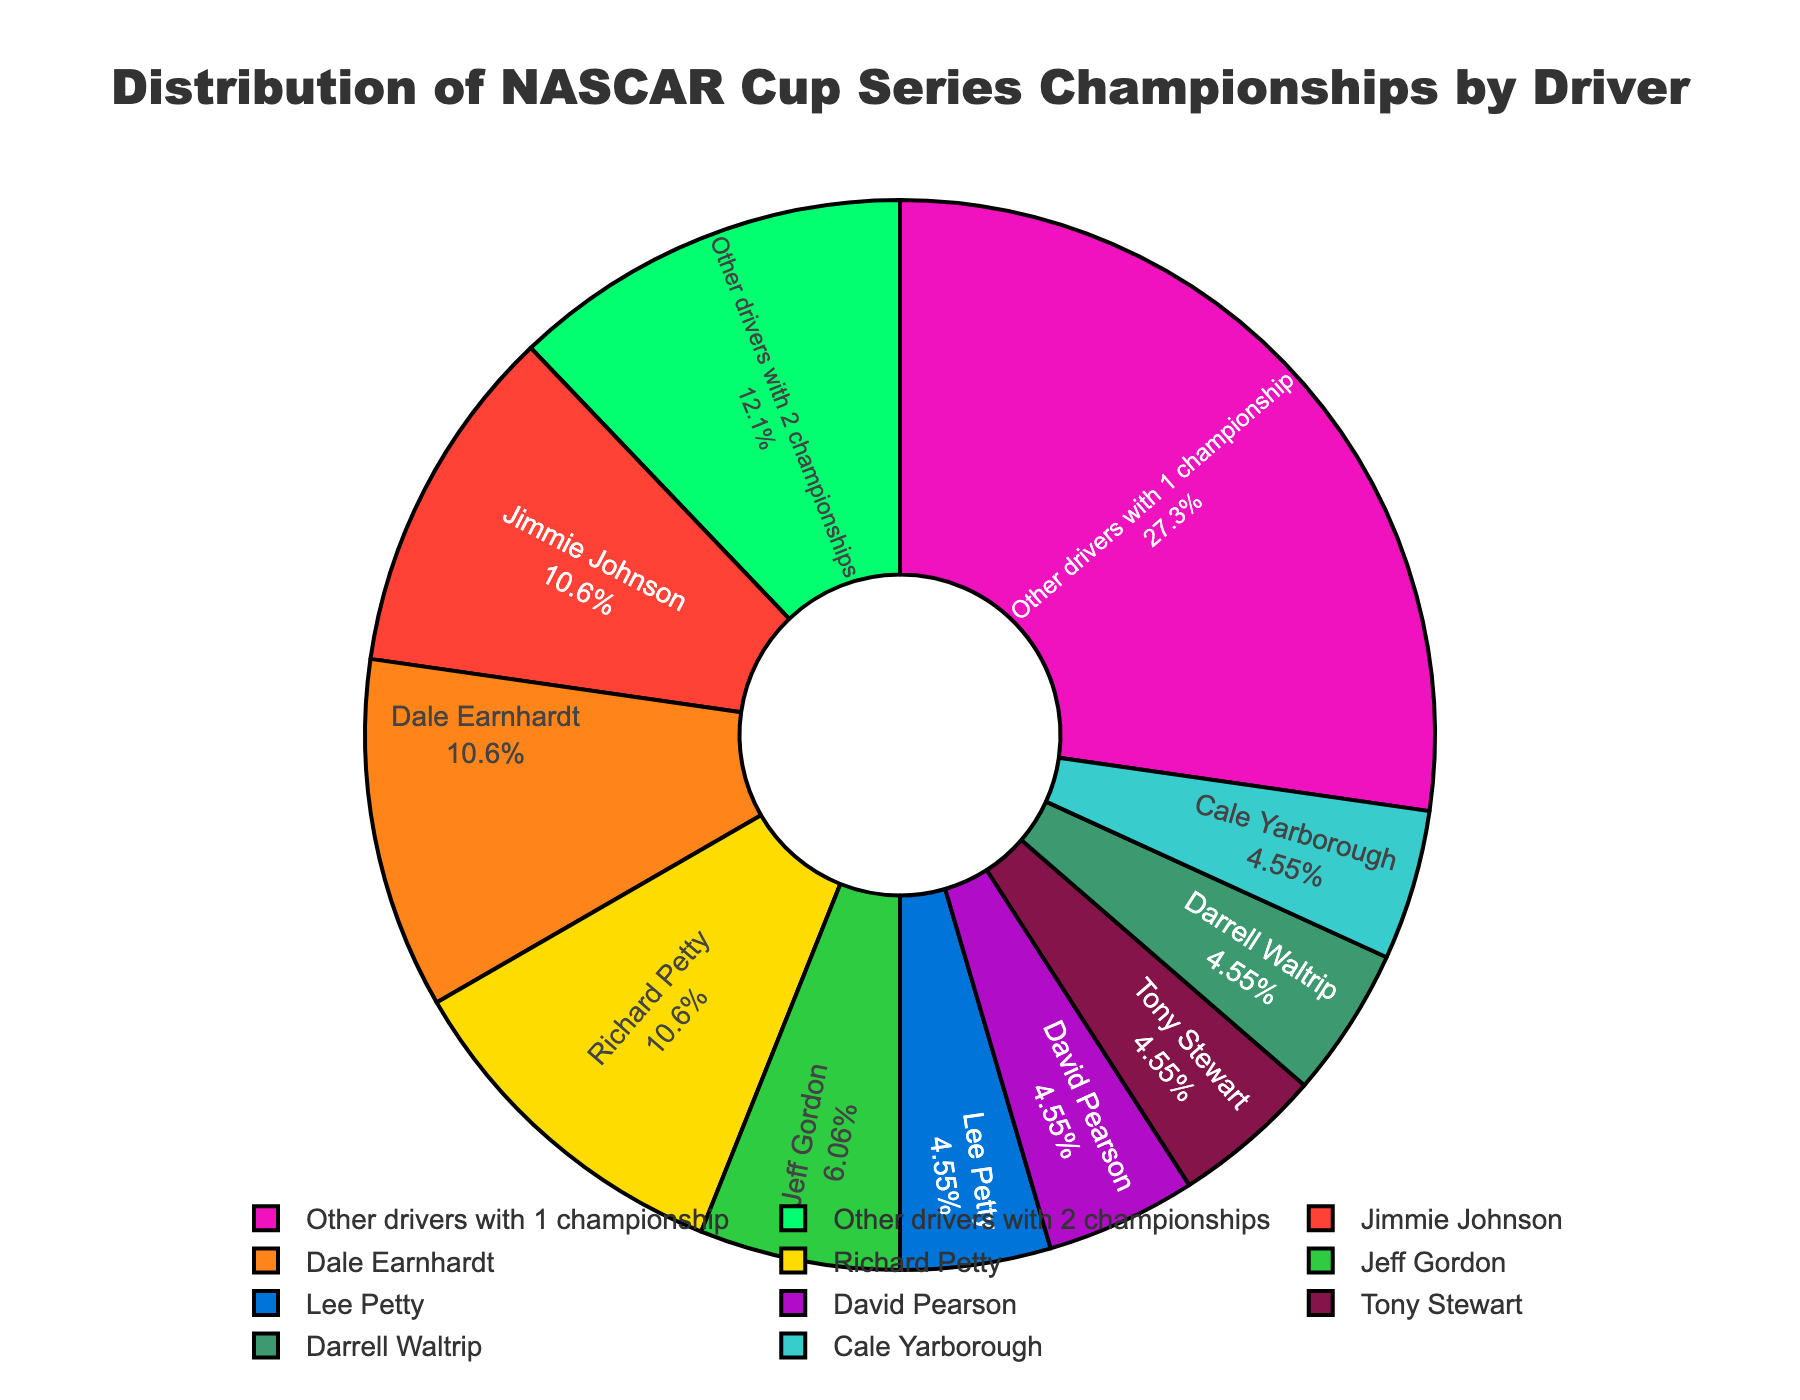Which driver has the most championships? From the figure, Jimmie Johnson, Dale Earnhardt, and Richard Petty each have the largest slice. They all have 7 championships.
Answer: Jimmie Johnson, Dale Earnhardt, Richard Petty Which driver has more championships, Jeff Gordon or Lee Petty? From the figure, Jeff Gordon has a larger slice than Lee Petty. Jeff Gordon has 4 championships, while Lee Petty has 3 championships.
Answer: Jeff Gordon What percentage of the total championships is held by drivers with 1 championship? This can be determined by looking at the slice labeled "Other drivers with 1 championship" which includes 18 championships. The total sum of all championships is 60. So, the percentage is (18/60) * 100 = 30%.
Answer: 30% How many drivers have exactly 3 championships? The figure shows separate slices for Lee Petty, David Pearson, Tony Stewart, Darrell Waltrip, and Cale Yarborough, each with 3 championships. There are 5 of them.
Answer: 5 Which color represents Tony Stewart's championships? Tony Stewart's slice is represented by the color green (third color used in the legend, identifiable through the visual attributes of the pie chart).
Answer: Green Compare the championship count of "Other drivers with 2 championships" to Jeff Gordon's championships. "Other drivers with 2 championships" have 8 championships in total, while Jeff Gordon has 4. 8 > 4.
Answer: 8 > 4 What is the total number of championships held by drivers with 3 championships? Adding the championships of drivers with 3 championships: Lee Petty (3), David Pearson (3), Tony Stewart (3), Darrell Waltrip (3), and Cale Yarborough (3), we get 5 * 3 = 15.
Answer: 15 What's the average number of championships for the drivers listed in the chart? The total championships is 60. There are 11 unique slices representing different driver categories. The average is 60 / 11 ≈ 5.45.
Answer: 5.45 